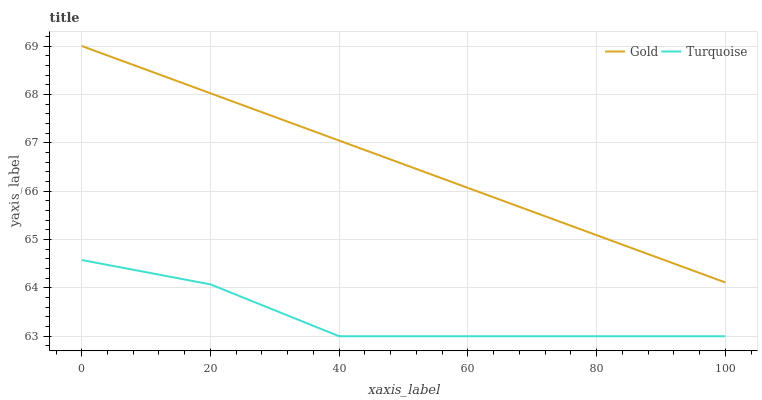Does Turquoise have the minimum area under the curve?
Answer yes or no. Yes. Does Gold have the maximum area under the curve?
Answer yes or no. Yes. Does Gold have the minimum area under the curve?
Answer yes or no. No. Is Gold the smoothest?
Answer yes or no. Yes. Is Turquoise the roughest?
Answer yes or no. Yes. Is Gold the roughest?
Answer yes or no. No. Does Turquoise have the lowest value?
Answer yes or no. Yes. Does Gold have the lowest value?
Answer yes or no. No. Does Gold have the highest value?
Answer yes or no. Yes. Is Turquoise less than Gold?
Answer yes or no. Yes. Is Gold greater than Turquoise?
Answer yes or no. Yes. Does Turquoise intersect Gold?
Answer yes or no. No. 